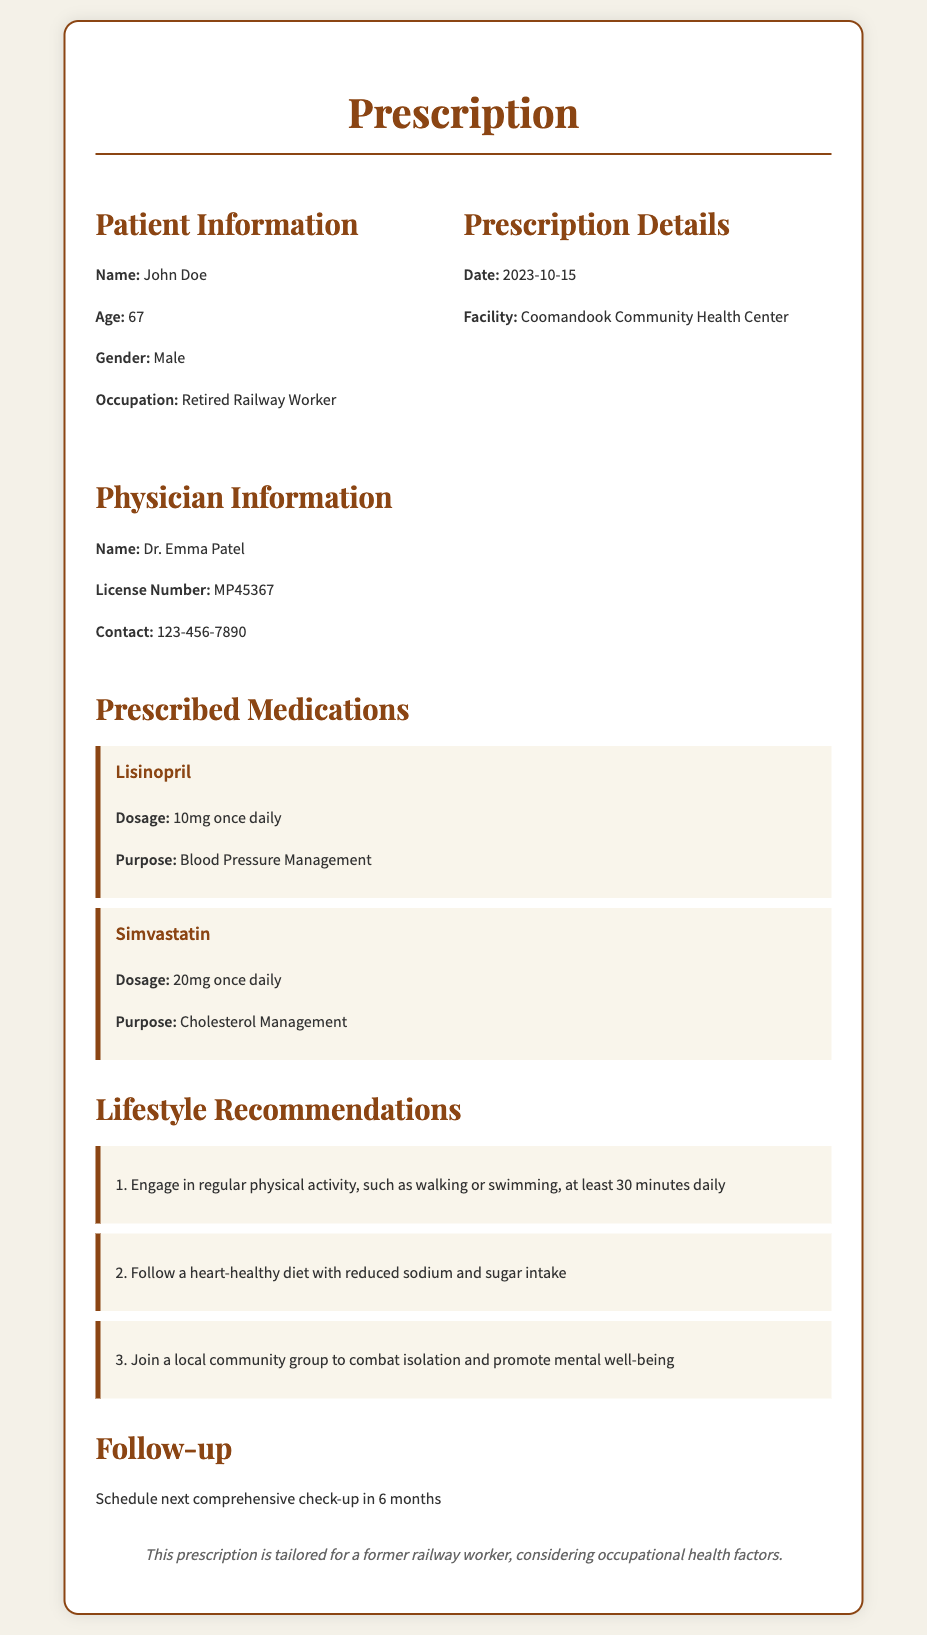What is the patient's name? The patient's name is John Doe, as specified in the patient information section.
Answer: John Doe What is the patient's age? The document states the patient's age as 67 years old.
Answer: 67 What medications were prescribed? The prescribed medications listed are Lisinopril and Simvastatin.
Answer: Lisinopril and Simvastatin What is the dosage of Simvastatin? The dosage for Simvastatin is detailed in the medication section as 20mg once daily.
Answer: 20mg once daily Who is the prescribing physician? The physician's name is mentioned as Dr. Emma Patel in the document.
Answer: Dr. Emma Patel What lifestyle recommendation involves physical activity? The document recommends engaging in regular physical activity, such as walking or swimming.
Answer: Regular physical activity When should the next check-up be scheduled? The next comprehensive check-up should be scheduled in 6 months, as indicated in the follow-up section.
Answer: 6 months What is the purpose of Lisinopril? The purpose of Lisinopril is blood pressure management, as specified in the medication details.
Answer: Blood Pressure Management What health facility is listed in the document? The health facility mentioned is the Coomandook Community Health Center.
Answer: Coomandook Community Health Center 